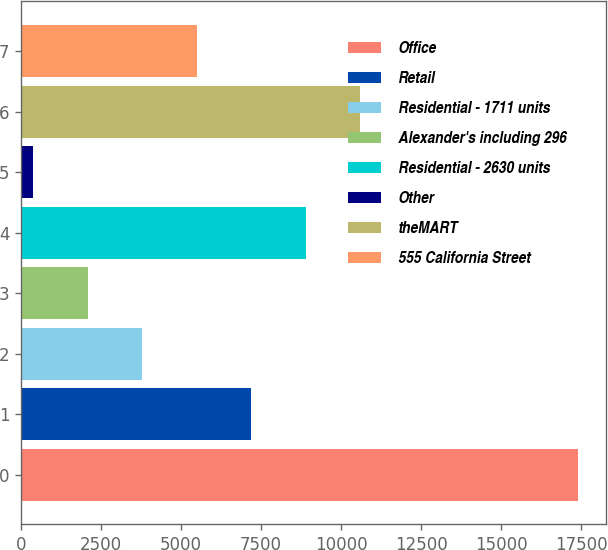<chart> <loc_0><loc_0><loc_500><loc_500><bar_chart><fcel>Office<fcel>Retail<fcel>Residential - 1711 units<fcel>Alexander's including 296<fcel>Residential - 2630 units<fcel>Other<fcel>theMART<fcel>555 California Street<nl><fcel>17412<fcel>7196.4<fcel>3791.2<fcel>2088.6<fcel>8899<fcel>386<fcel>10601.6<fcel>5493.8<nl></chart> 